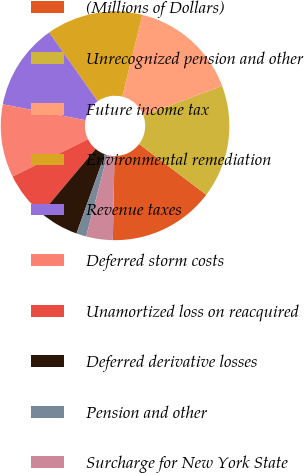Convert chart to OTSL. <chart><loc_0><loc_0><loc_500><loc_500><pie_chart><fcel>(Millions of Dollars)<fcel>Unrecognized pension and other<fcel>Future income tax<fcel>Environmental remediation<fcel>Revenue taxes<fcel>Deferred storm costs<fcel>Unamortized loss on reacquired<fcel>Deferred derivative losses<fcel>Pension and other<fcel>Surcharge for New York State<nl><fcel>15.02%<fcel>15.96%<fcel>15.49%<fcel>13.61%<fcel>12.21%<fcel>10.33%<fcel>6.57%<fcel>5.64%<fcel>1.41%<fcel>3.76%<nl></chart> 